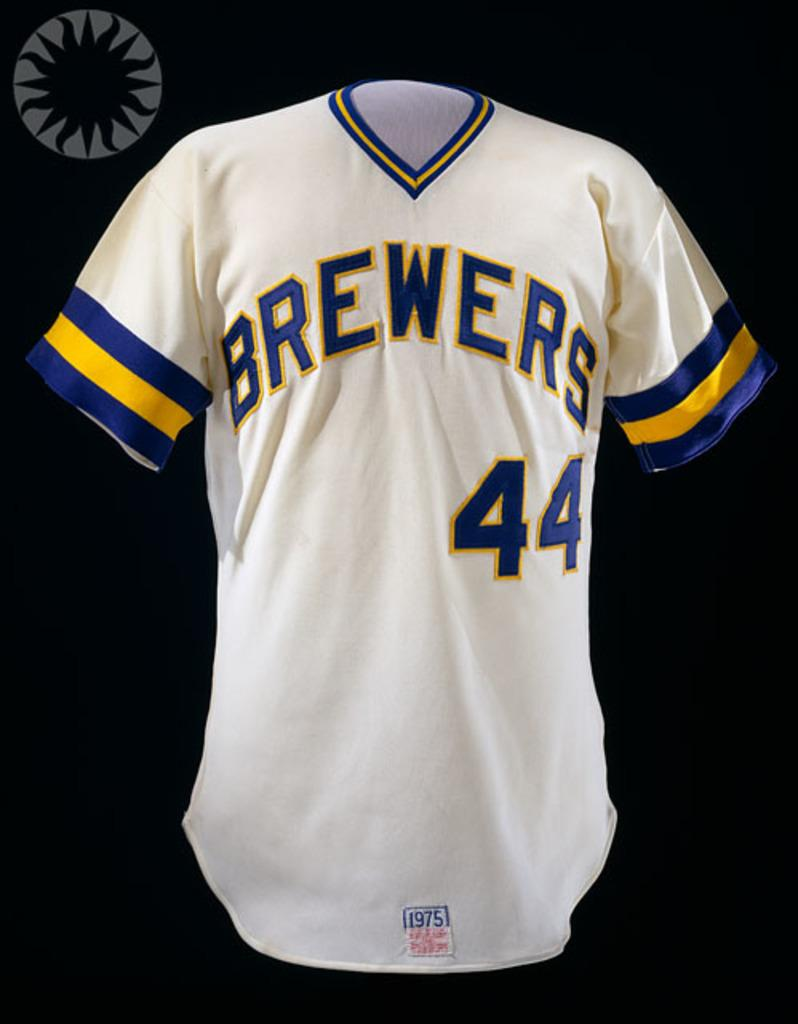<image>
Give a short and clear explanation of the subsequent image. A white Brewers shirt with the number 44 on it 